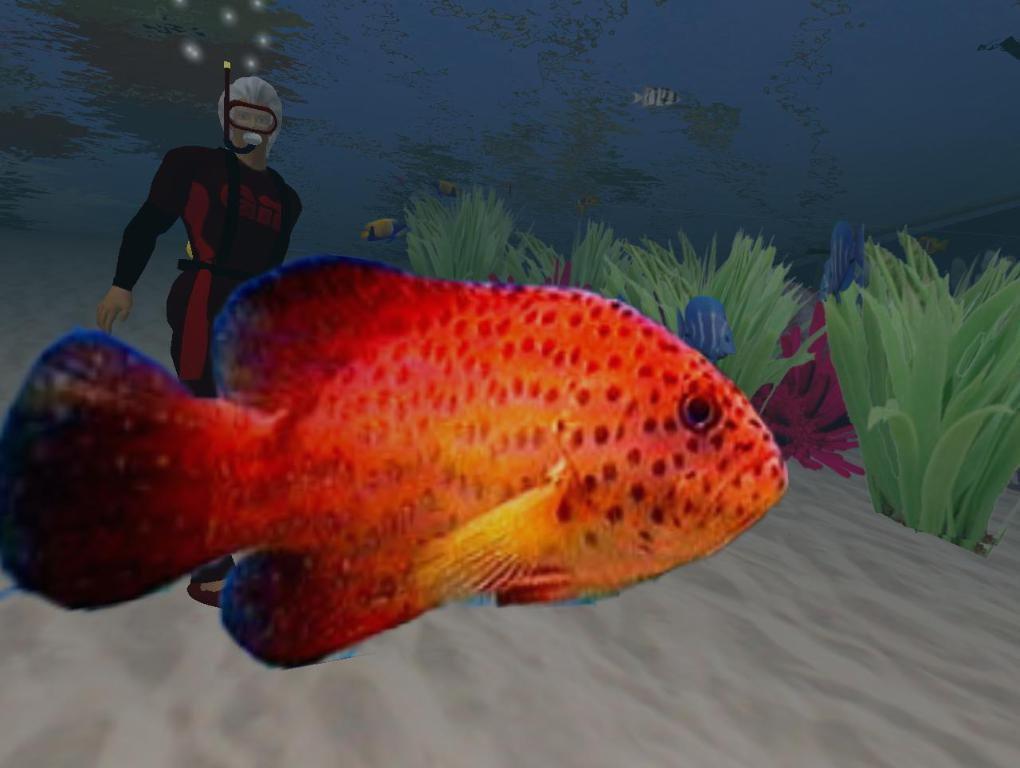What type of animals can be seen in the image? There are fishes in the image. Can you describe the person in the image? There is a person in the image. What is the primary element in which the fishes are situated? There is water visible in the image, and the fishes are situated in it. What type of vegetation is present in the image? There are plants in the image. What type of crown is the person wearing in the image? There is no crown present in the image; the person is not wearing any headgear. Can you tell me how many boats are visible in the image? There are no boats present in the image. 